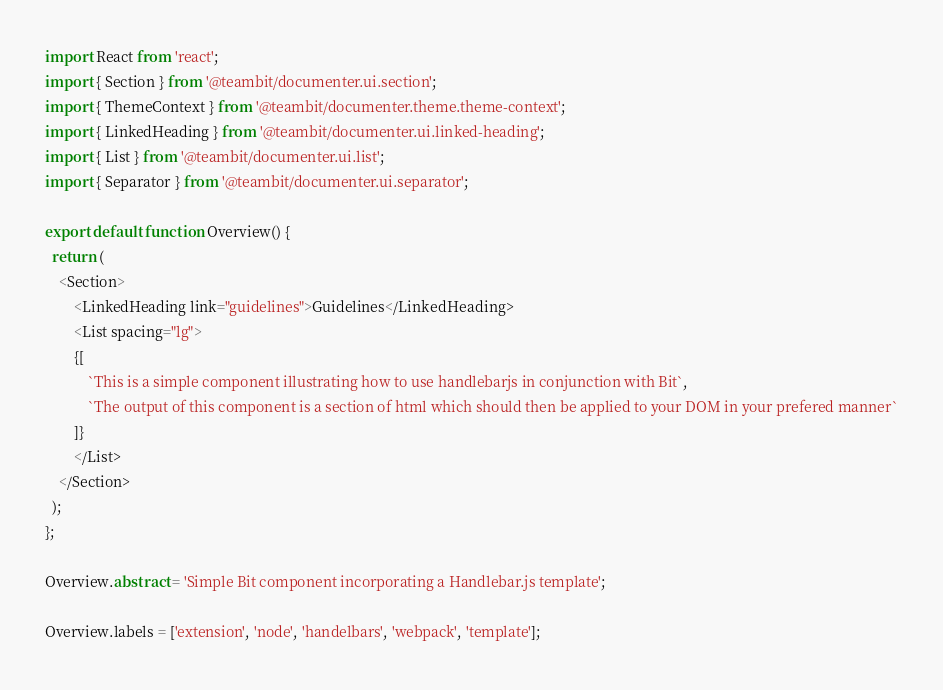Convert code to text. <code><loc_0><loc_0><loc_500><loc_500><_TypeScript_>
import React from 'react';
import { Section } from '@teambit/documenter.ui.section';
import { ThemeContext } from '@teambit/documenter.theme.theme-context';
import { LinkedHeading } from '@teambit/documenter.ui.linked-heading';
import { List } from '@teambit/documenter.ui.list';
import { Separator } from '@teambit/documenter.ui.separator';

export default function Overview() {
  return (
    <Section>
        <LinkedHeading link="guidelines">Guidelines</LinkedHeading>
        <List spacing="lg">
        {[
            `This is a simple component illustrating how to use handlebarjs in conjunction with Bit`,
            `The output of this component is a section of html which should then be applied to your DOM in your prefered manner`
        ]}
        </List>
    </Section>
  );
};

Overview.abstract = 'Simple Bit component incorporating a Handlebar.js template';

Overview.labels = ['extension', 'node', 'handelbars', 'webpack', 'template'];</code> 